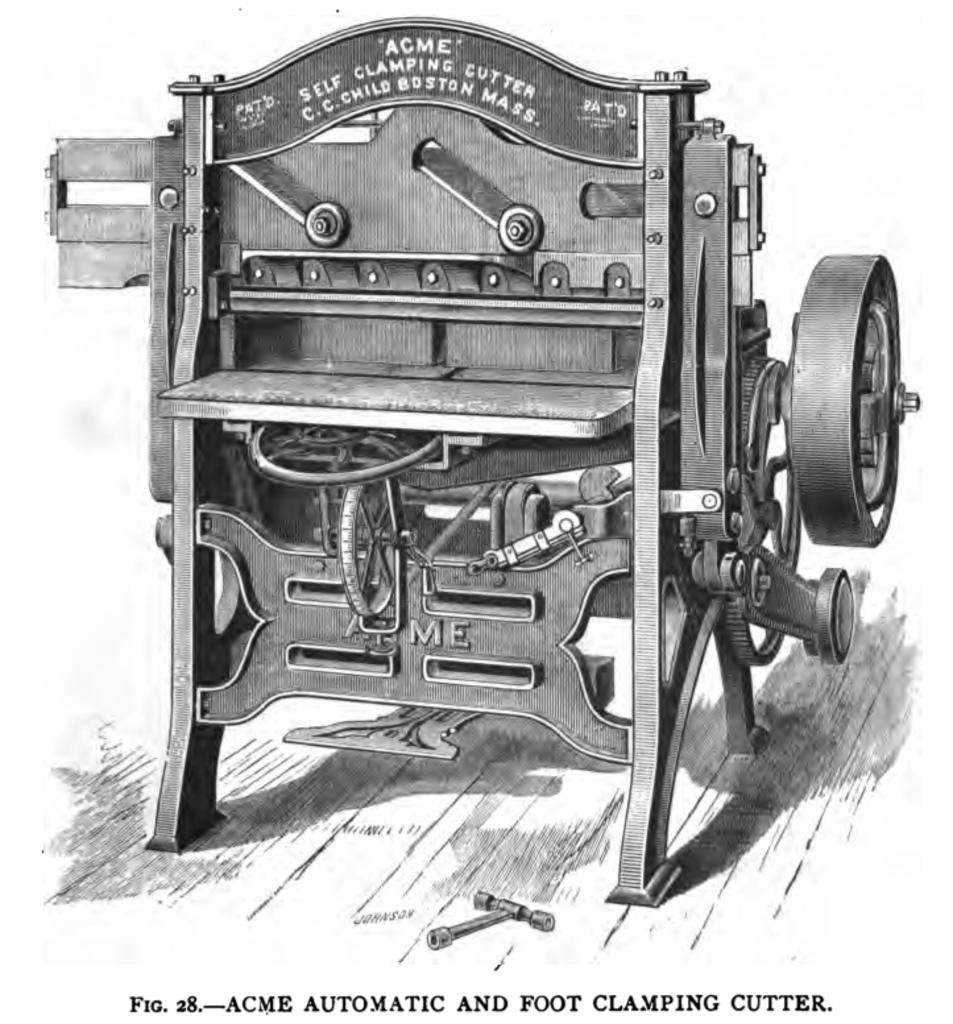What is the color scheme of the image? The image is black and white. What is the main subject of the image? There is a picture of a machine in the image. Is there any additional information or marking in the image? Yes, there is a watermark at the bottom of the image. How many bricks are stacked on top of each other in the image? There are no bricks present in the image; it features a picture of a machine. What route does the machine follow in the image? The image does not show the machine in motion or following a specific route. 